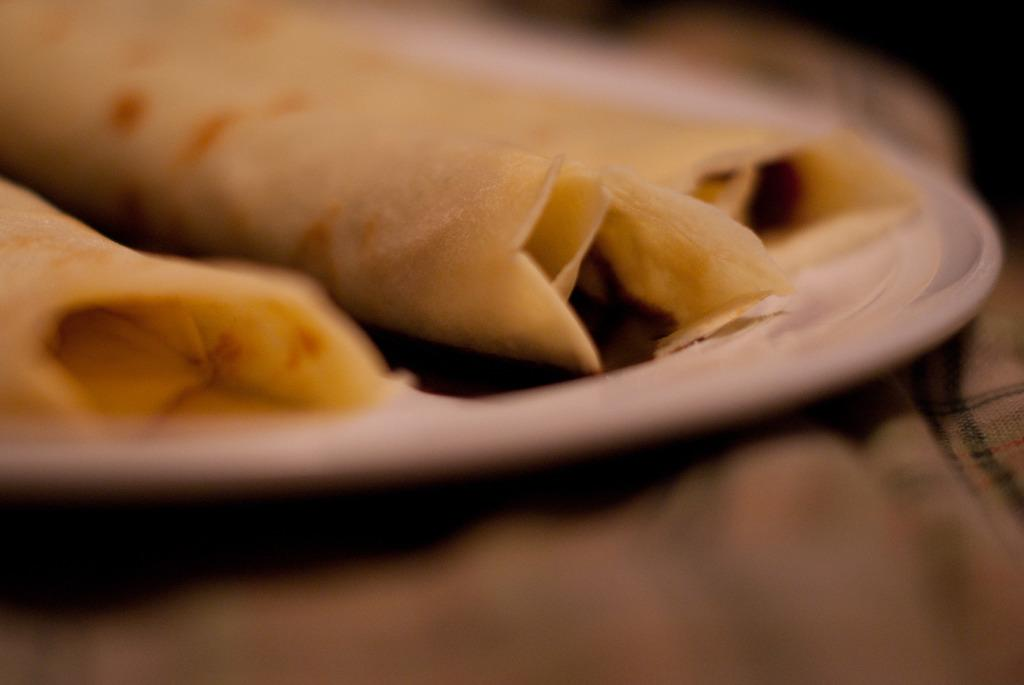What is on the white plate in the image? There is food on a white plate in the image. What can be observed about the edges of the image? The top and bottom of the image have a blurred view. What type of material is present in the image? There is a cloth in the image. How many hands are visible in the image? There are no hands visible in the image. What type of railway is present in the image? There is no railway present in the image. 